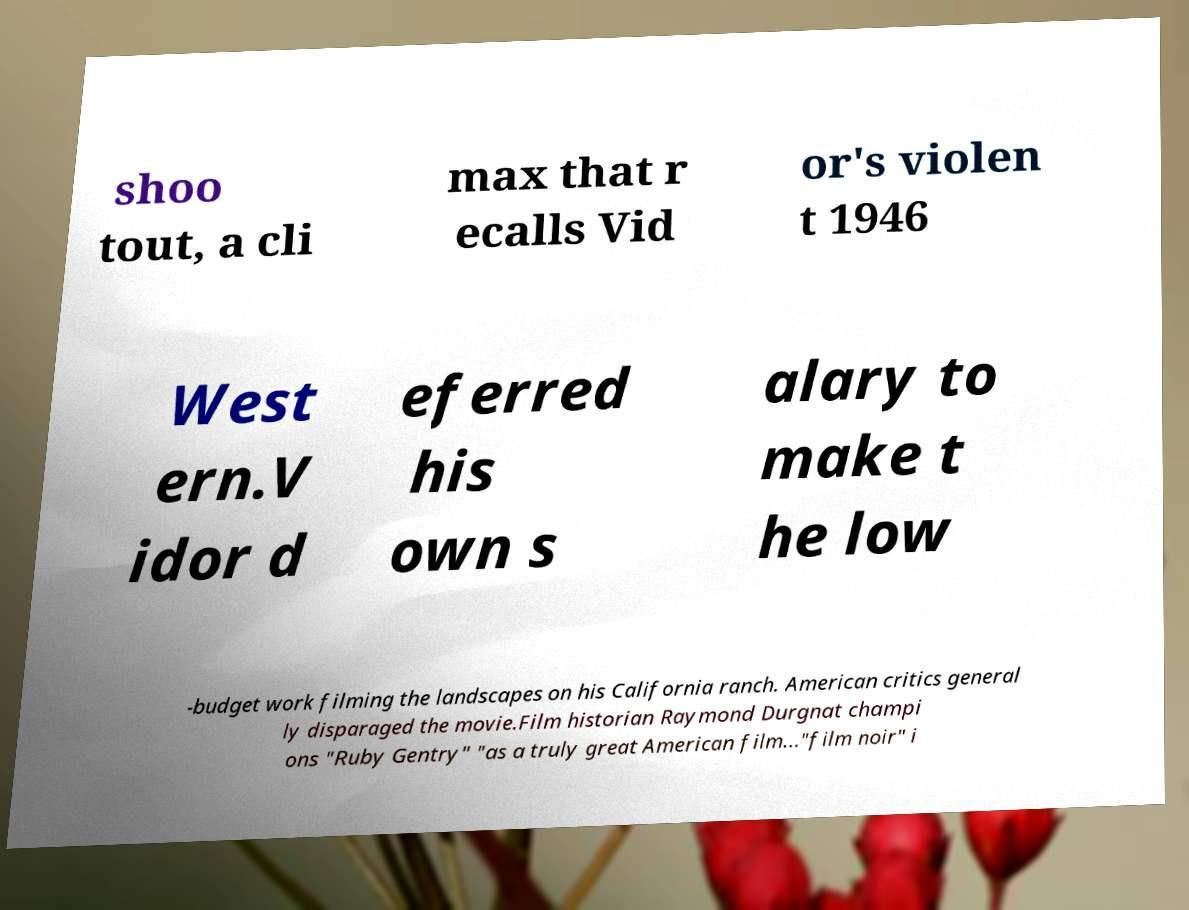Can you accurately transcribe the text from the provided image for me? shoo tout, a cli max that r ecalls Vid or's violen t 1946 West ern.V idor d eferred his own s alary to make t he low -budget work filming the landscapes on his California ranch. American critics general ly disparaged the movie.Film historian Raymond Durgnat champi ons "Ruby Gentry" "as a truly great American film..."film noir" i 